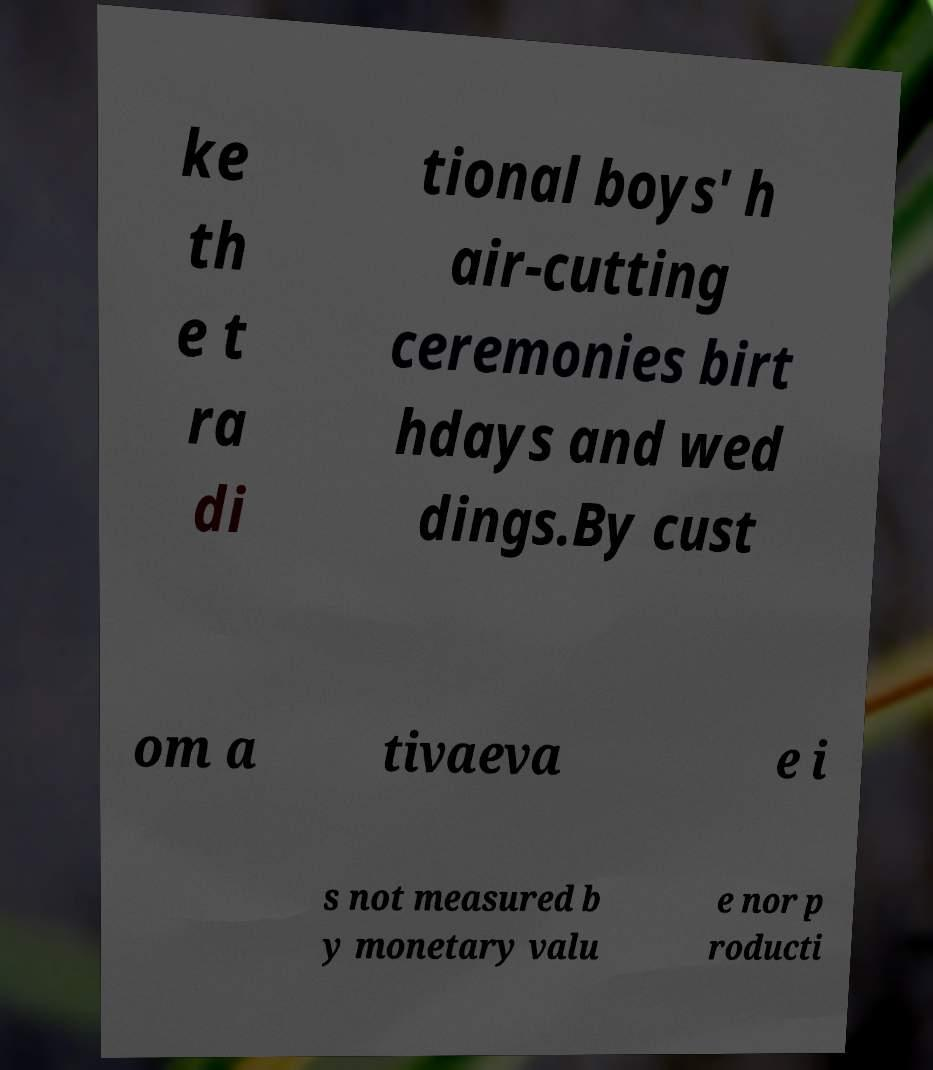Could you assist in decoding the text presented in this image and type it out clearly? ke th e t ra di tional boys' h air-cutting ceremonies birt hdays and wed dings.By cust om a tivaeva e i s not measured b y monetary valu e nor p roducti 